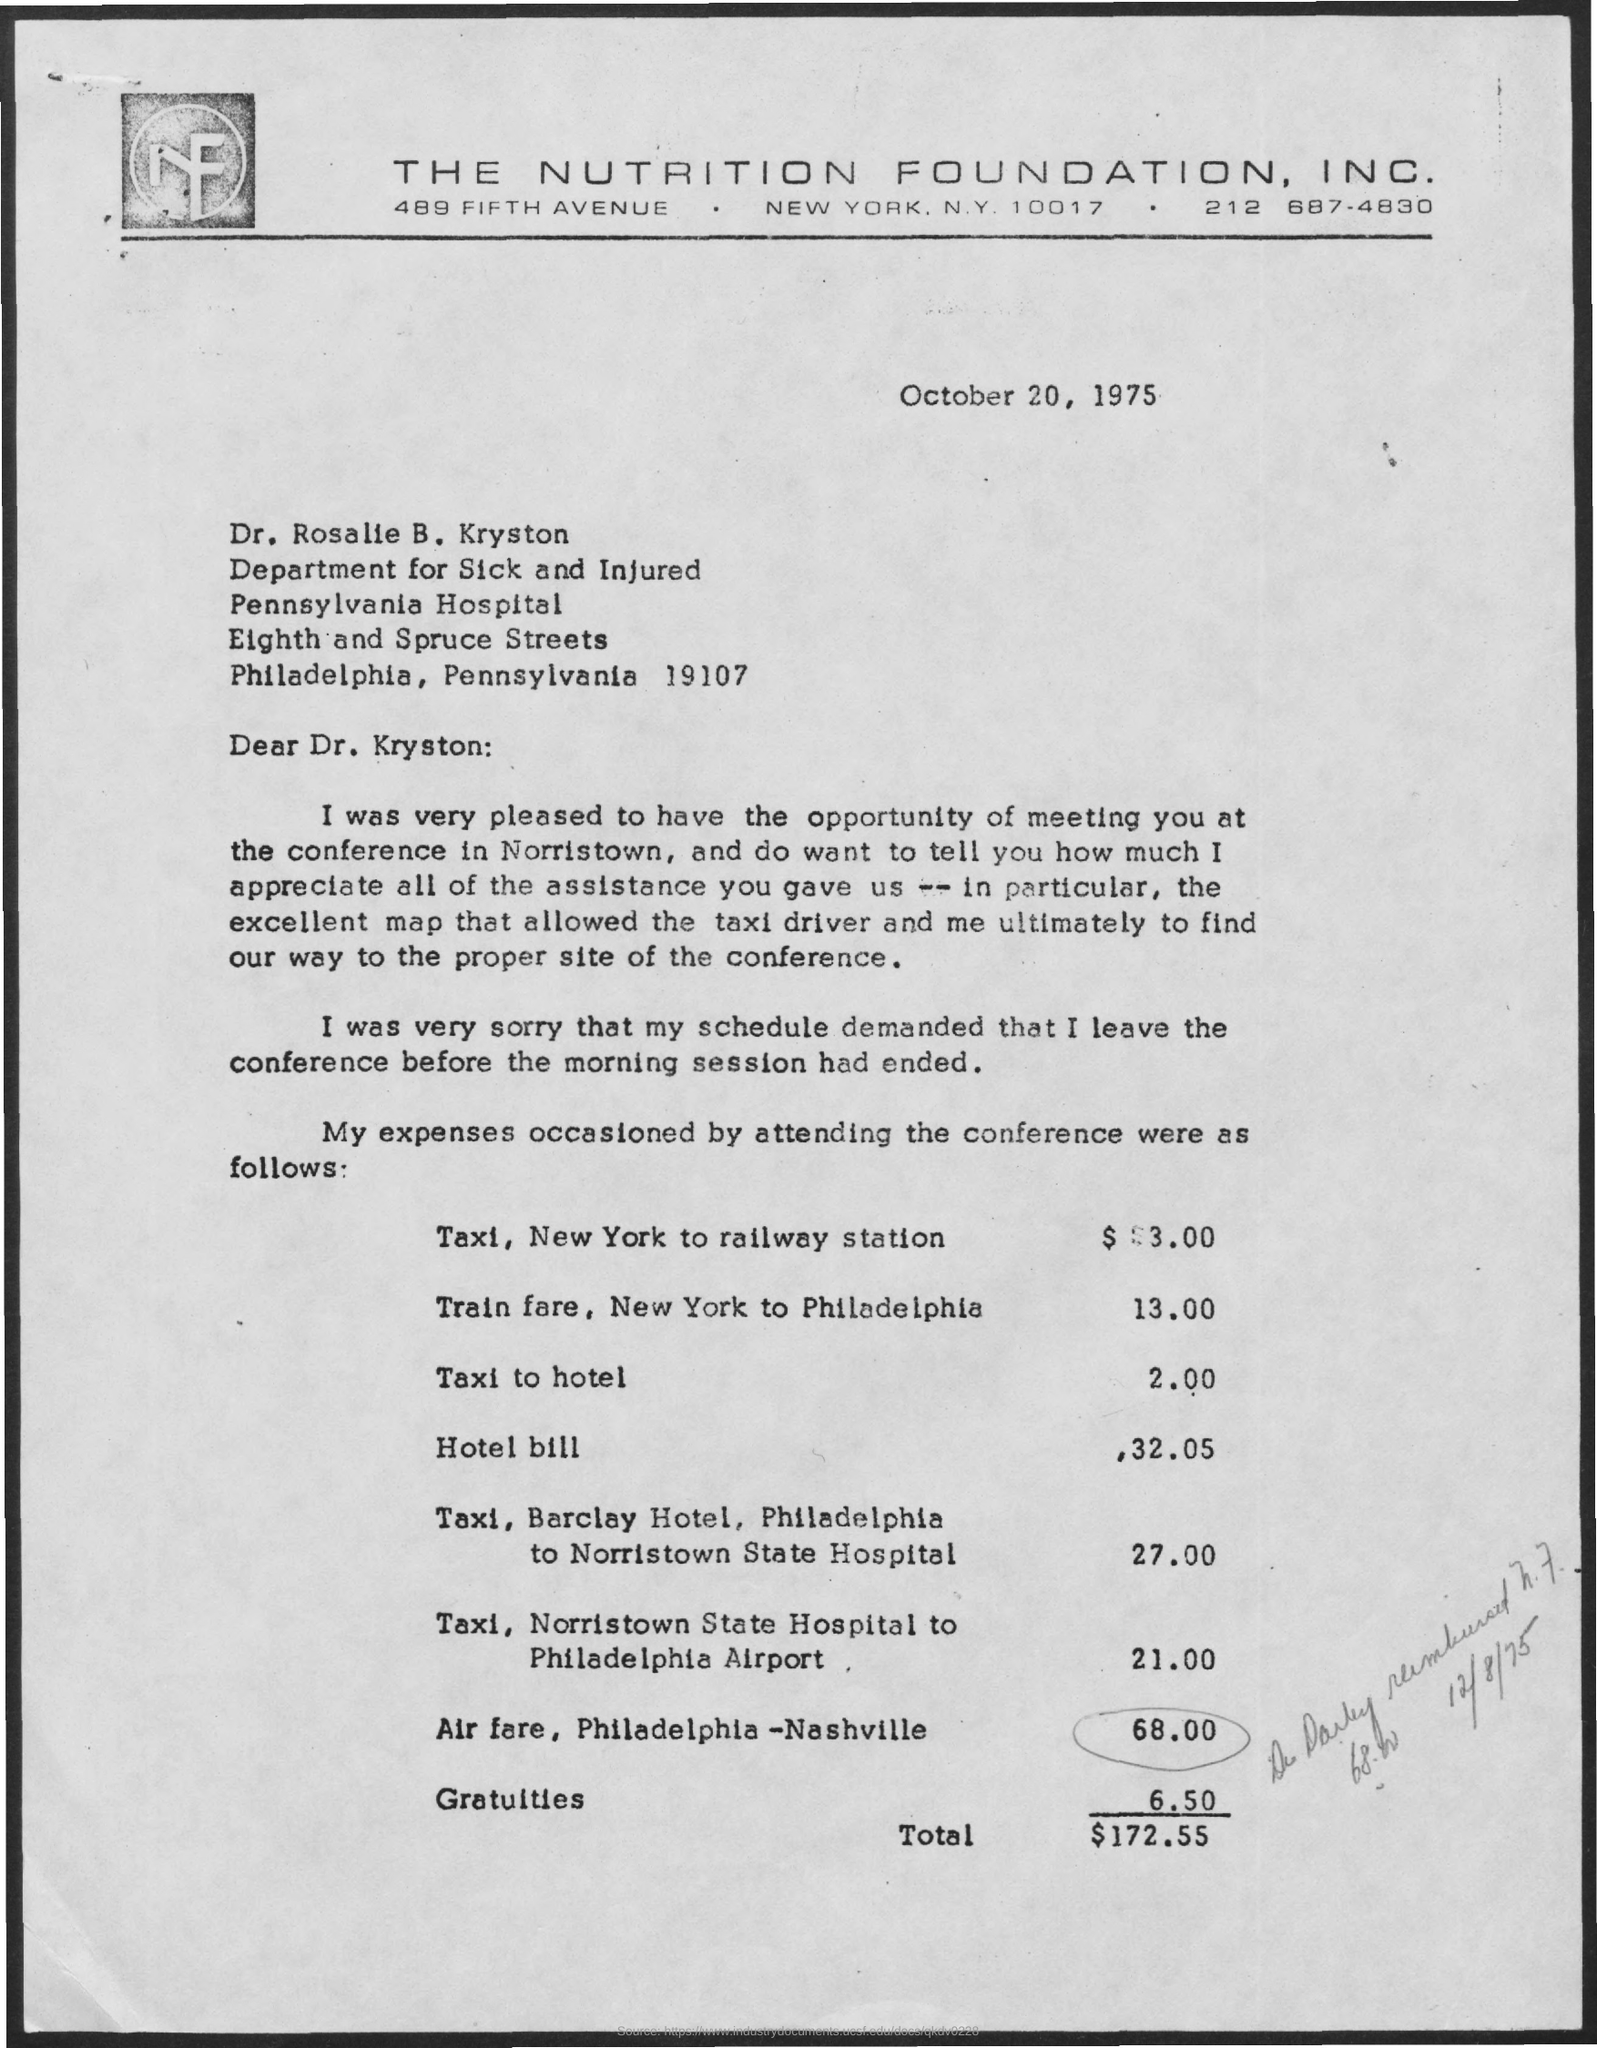What is the contact of the nutrition foundation, inc.?
Give a very brief answer. 212 687-4830. To whom this letter is written to?
Give a very brief answer. Dr. Rosalie B. Kryston. What is the total amount?
Ensure brevity in your answer.  $172.55. What is the taxi fare from new york to railway station?
Your answer should be very brief. $3.00. What is train fare from  New York to Philadelphia?
Your answer should be very brief. 13.00. The letter is dated on?
Your answer should be very brief. October 20, 1975. What is taxi fare to hotel?
Your answer should be very brief. 2.00. 